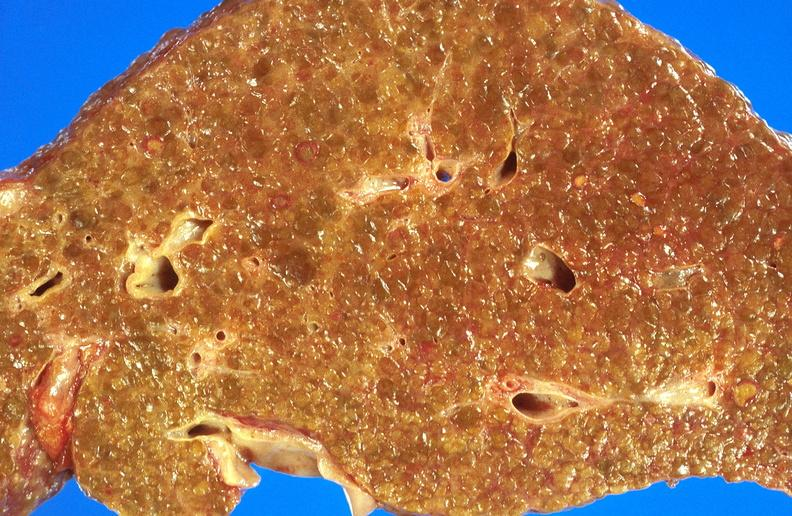s hepatobiliary present?
Answer the question using a single word or phrase. Yes 